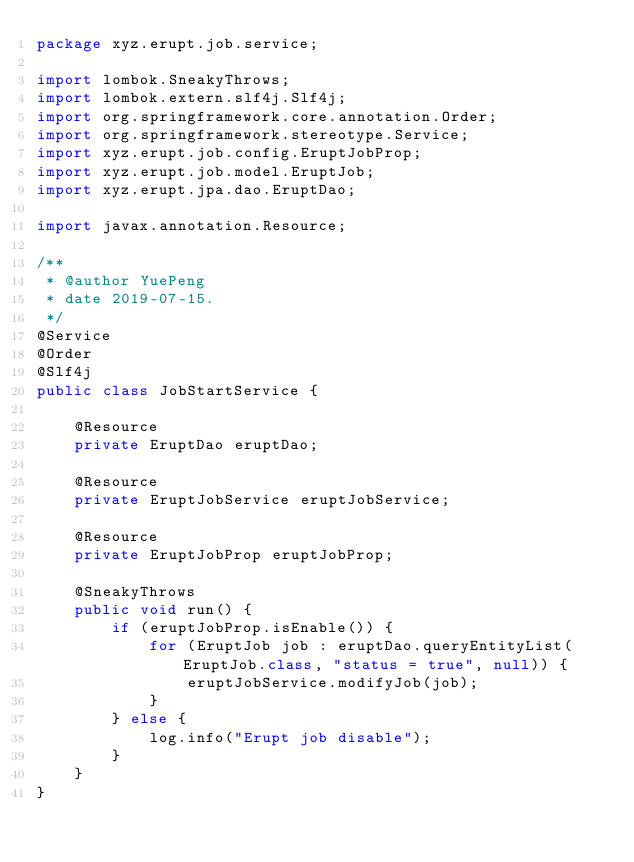<code> <loc_0><loc_0><loc_500><loc_500><_Java_>package xyz.erupt.job.service;

import lombok.SneakyThrows;
import lombok.extern.slf4j.Slf4j;
import org.springframework.core.annotation.Order;
import org.springframework.stereotype.Service;
import xyz.erupt.job.config.EruptJobProp;
import xyz.erupt.job.model.EruptJob;
import xyz.erupt.jpa.dao.EruptDao;

import javax.annotation.Resource;

/**
 * @author YuePeng
 * date 2019-07-15.
 */
@Service
@Order
@Slf4j
public class JobStartService {

    @Resource
    private EruptDao eruptDao;

    @Resource
    private EruptJobService eruptJobService;

    @Resource
    private EruptJobProp eruptJobProp;

    @SneakyThrows
    public void run() {
        if (eruptJobProp.isEnable()) {
            for (EruptJob job : eruptDao.queryEntityList(EruptJob.class, "status = true", null)) {
                eruptJobService.modifyJob(job);
            }
        } else {
            log.info("Erupt job disable");
        }
    }
}
</code> 